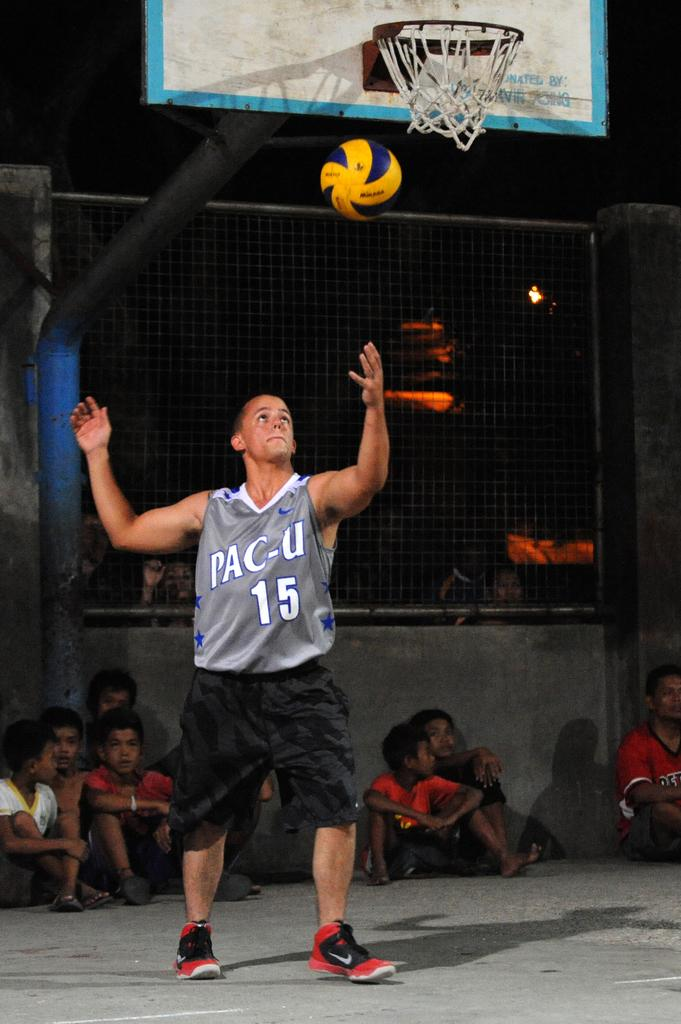<image>
Provide a brief description of the given image. a man wearing a Pac U 15 jersey throws a basketball 